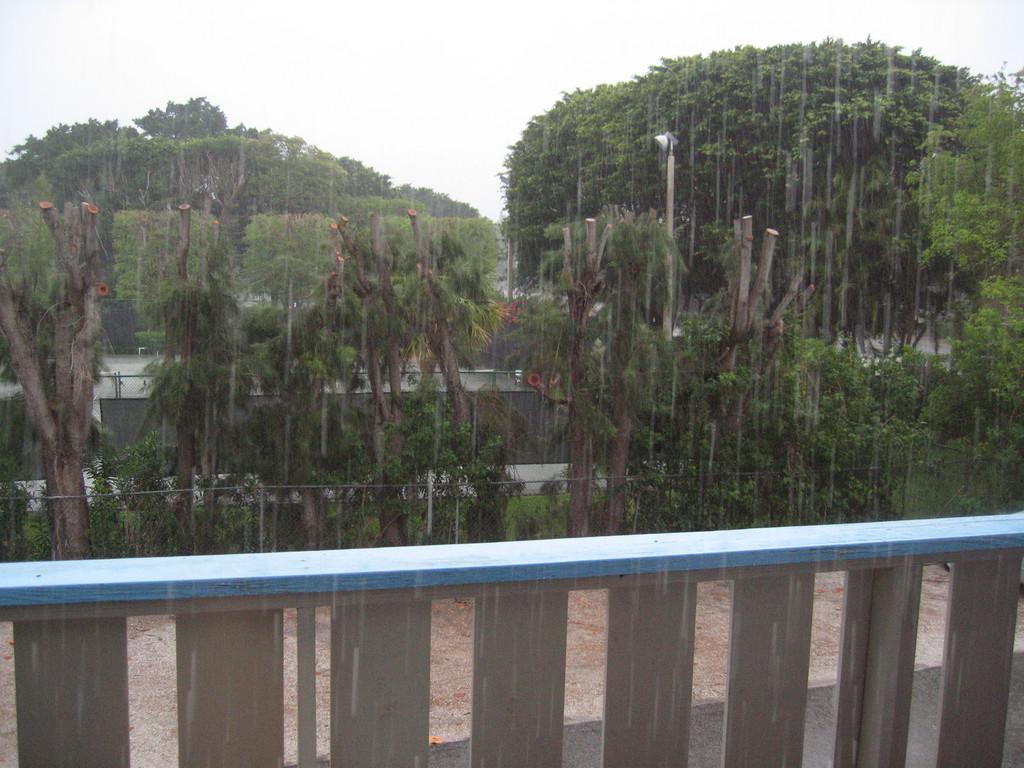Can you describe this image briefly? In this image I can see few trees, roads, light pole and the fencing. The sky is in white color. 